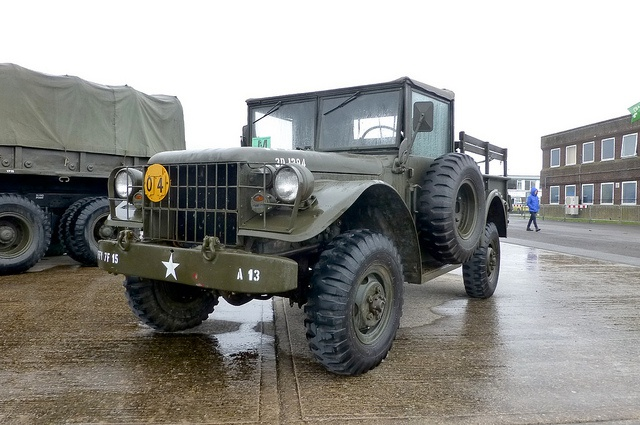Describe the objects in this image and their specific colors. I can see truck in white, black, gray, darkgray, and darkgreen tones, truck in white, gray, and black tones, and people in white, blue, lightblue, navy, and gray tones in this image. 